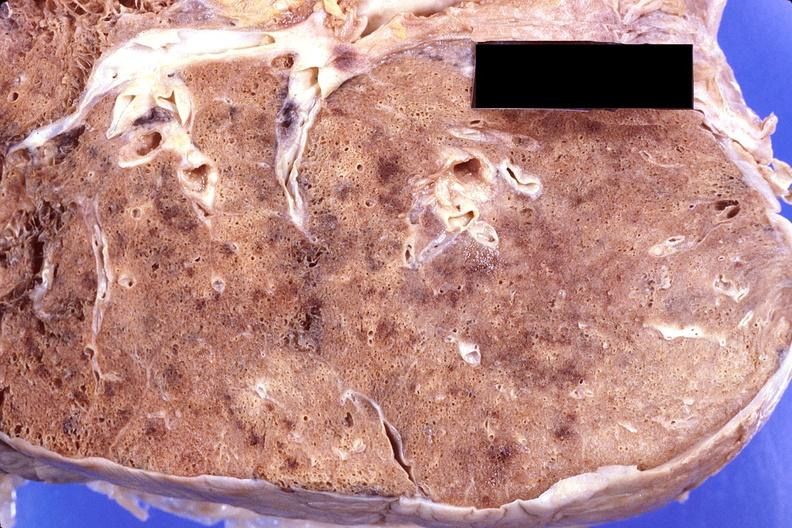what is present?
Answer the question using a single word or phrase. Respiratory 